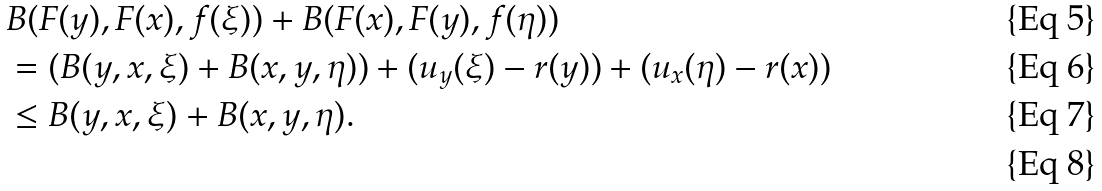<formula> <loc_0><loc_0><loc_500><loc_500>& B ( F ( y ) , F ( x ) , f ( \xi ) ) + B ( F ( x ) , F ( y ) , f ( \eta ) ) \\ & = ( B ( y , x , \xi ) + B ( x , y , \eta ) ) + ( u _ { y } ( \xi ) - r ( y ) ) + ( u _ { x } ( \eta ) - r ( x ) ) \\ & \leq B ( y , x , \xi ) + B ( x , y , \eta ) . \\</formula> 